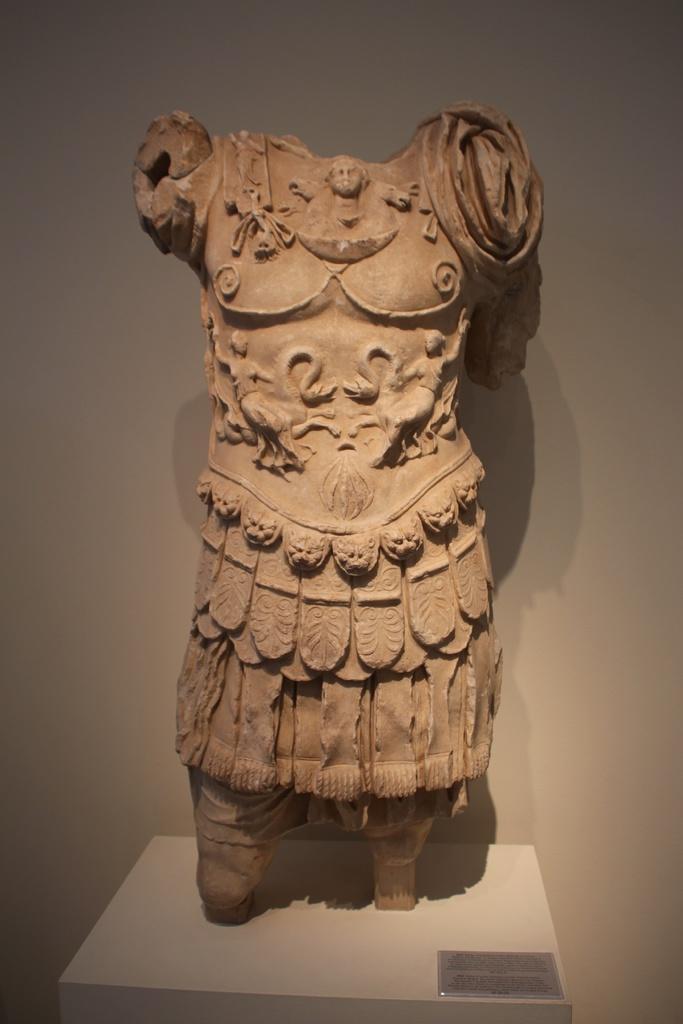In one or two sentences, can you explain what this image depicts? In this picture we can see a sculpture on the platform and we can see board. In the background of the image we can see wall. 